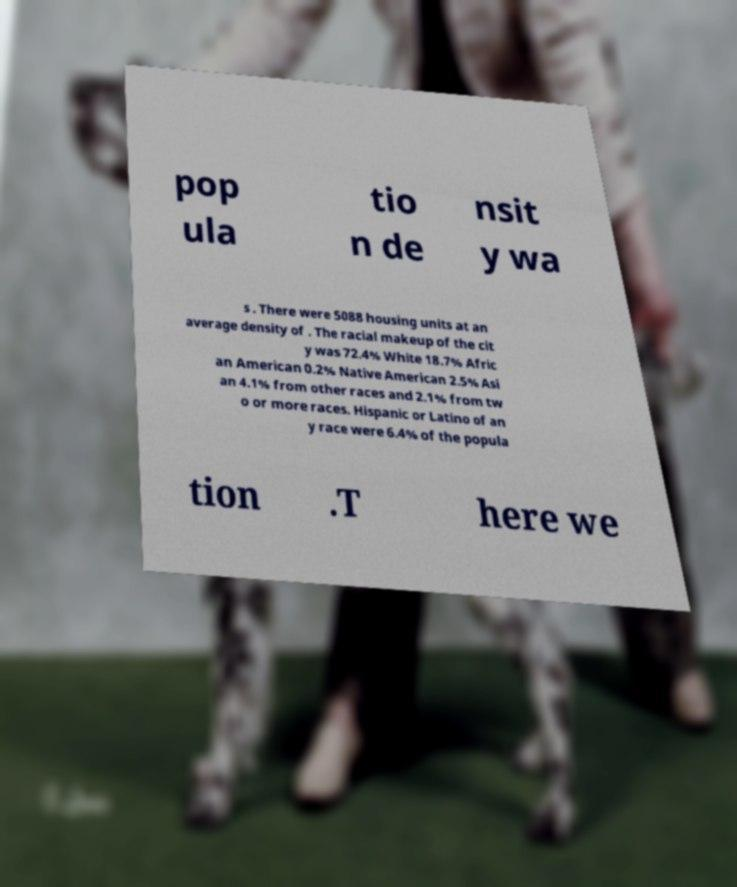What messages or text are displayed in this image? I need them in a readable, typed format. pop ula tio n de nsit y wa s . There were 5088 housing units at an average density of . The racial makeup of the cit y was 72.4% White 18.7% Afric an American 0.2% Native American 2.5% Asi an 4.1% from other races and 2.1% from tw o or more races. Hispanic or Latino of an y race were 6.4% of the popula tion .T here we 